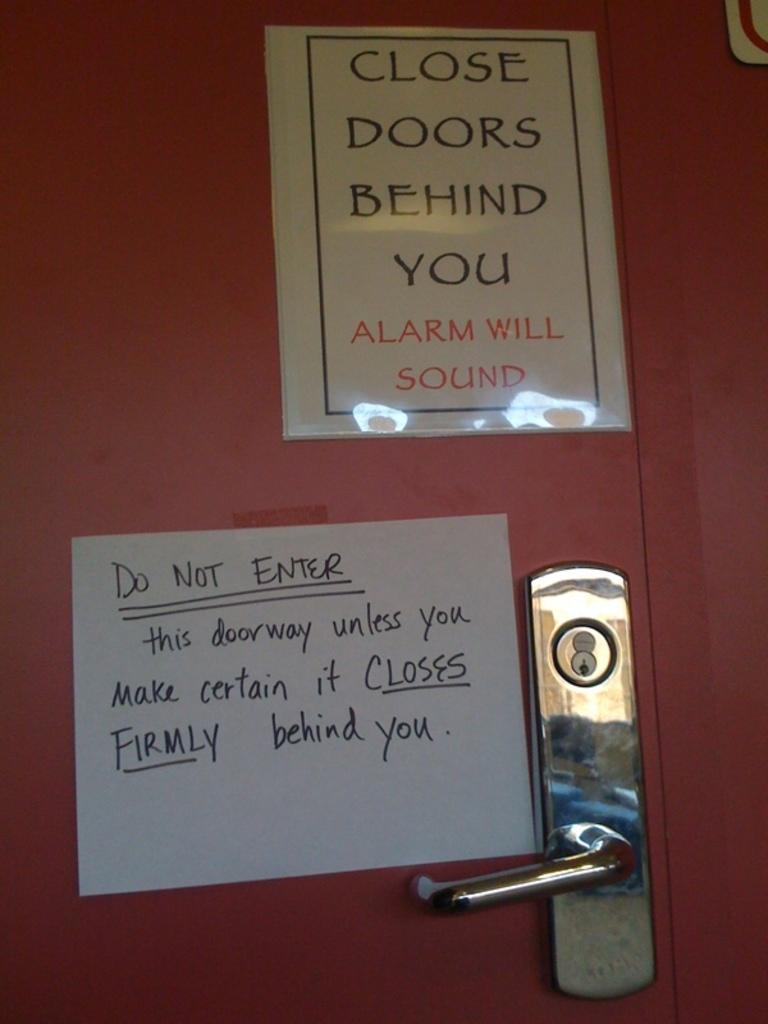What will sound?
Provide a short and direct response. Alarm. What must you do if you enter the doorway?
Ensure brevity in your answer.  Make certain it closes firmly behind you. 